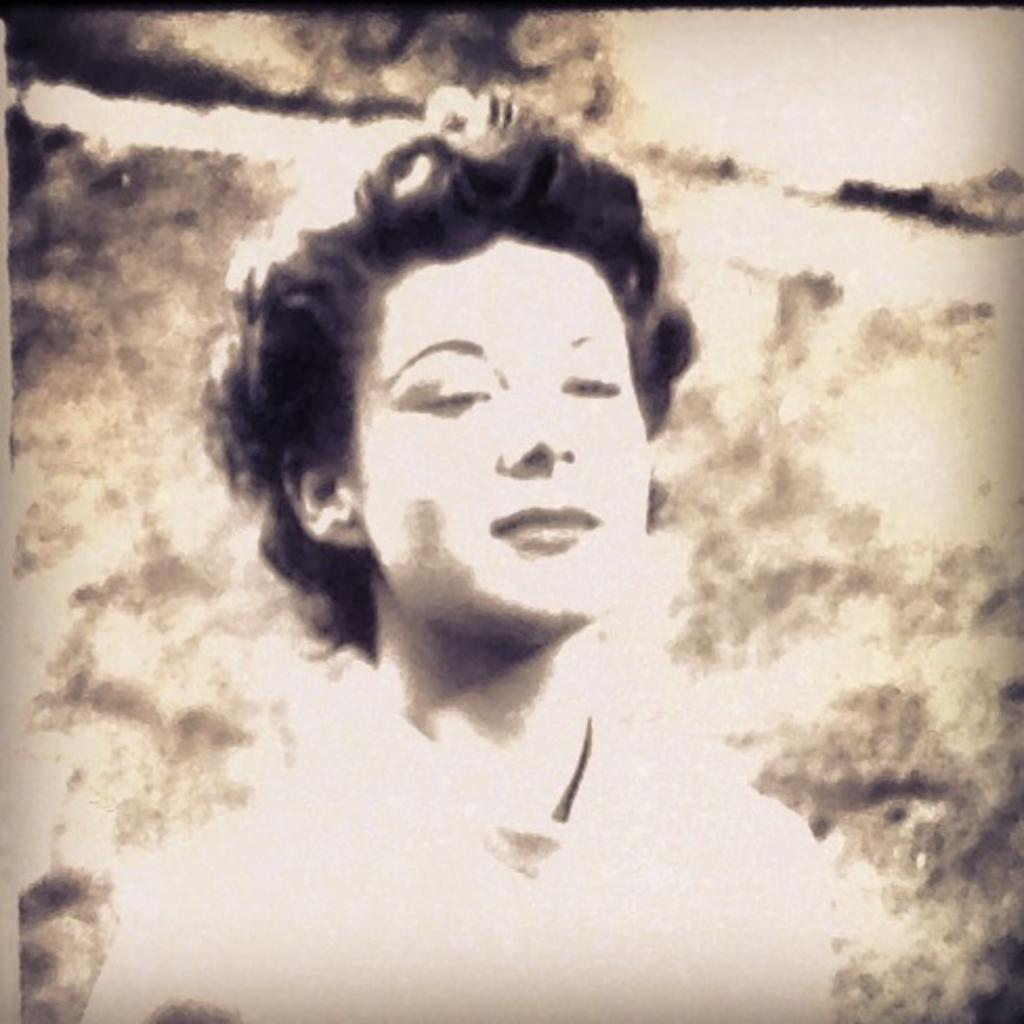What is the color scheme of the image? The image is monochrome. What is the main subject of the image? There is a lady in the image. How many boys are present in the image? There are no boys present in the image; it features a lady. What type of approval is the lady seeking in the image? There is no indication in the image that the lady is seeking any approval. What is the condition of the lady's wrist in the image? There is no information about the lady's wrist in the image. 